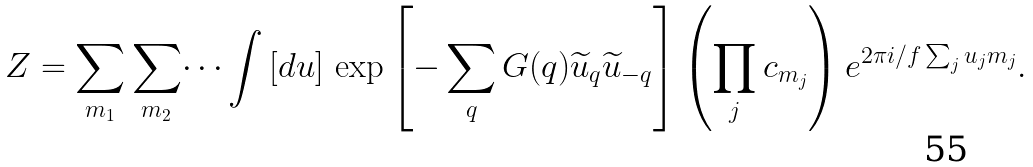<formula> <loc_0><loc_0><loc_500><loc_500>Z = \sum _ { m _ { 1 } } \sum _ { m _ { 2 } } \dots \int \, [ d u ] \, \exp \left [ - \sum _ { q } G ( q ) \widetilde { u } _ { q } \widetilde { u } _ { - q } \right ] \left ( \prod _ { j } c _ { m _ { j } } \right ) e ^ { 2 \pi i / f \sum _ { j } u _ { j } m _ { j } } .</formula> 